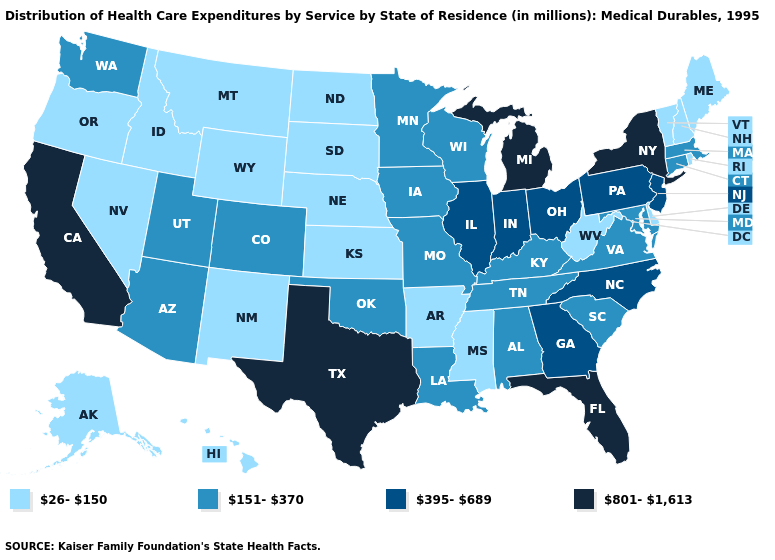Which states have the lowest value in the South?
Concise answer only. Arkansas, Delaware, Mississippi, West Virginia. Does the map have missing data?
Keep it brief. No. How many symbols are there in the legend?
Short answer required. 4. Name the states that have a value in the range 395-689?
Quick response, please. Georgia, Illinois, Indiana, New Jersey, North Carolina, Ohio, Pennsylvania. Does the first symbol in the legend represent the smallest category?
Be succinct. Yes. What is the value of Oregon?
Be succinct. 26-150. Name the states that have a value in the range 801-1,613?
Concise answer only. California, Florida, Michigan, New York, Texas. Name the states that have a value in the range 151-370?
Give a very brief answer. Alabama, Arizona, Colorado, Connecticut, Iowa, Kentucky, Louisiana, Maryland, Massachusetts, Minnesota, Missouri, Oklahoma, South Carolina, Tennessee, Utah, Virginia, Washington, Wisconsin. What is the highest value in states that border Massachusetts?
Keep it brief. 801-1,613. What is the value of Rhode Island?
Keep it brief. 26-150. Among the states that border Arkansas , does Texas have the highest value?
Short answer required. Yes. Name the states that have a value in the range 151-370?
Write a very short answer. Alabama, Arizona, Colorado, Connecticut, Iowa, Kentucky, Louisiana, Maryland, Massachusetts, Minnesota, Missouri, Oklahoma, South Carolina, Tennessee, Utah, Virginia, Washington, Wisconsin. Does Florida have the highest value in the South?
Give a very brief answer. Yes. Name the states that have a value in the range 26-150?
Be succinct. Alaska, Arkansas, Delaware, Hawaii, Idaho, Kansas, Maine, Mississippi, Montana, Nebraska, Nevada, New Hampshire, New Mexico, North Dakota, Oregon, Rhode Island, South Dakota, Vermont, West Virginia, Wyoming. Is the legend a continuous bar?
Give a very brief answer. No. 